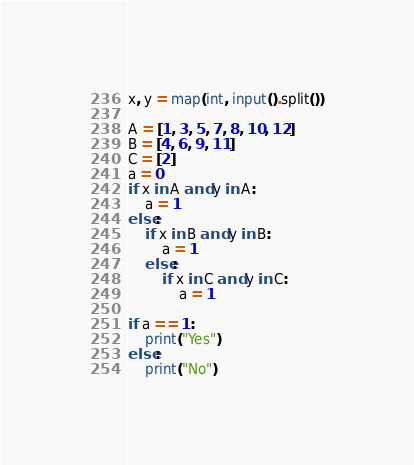<code> <loc_0><loc_0><loc_500><loc_500><_Python_>x, y = map(int, input().split())

A = [1, 3, 5, 7, 8, 10, 12]
B = [4, 6, 9, 11]
C = [2]
a = 0
if x in A and y in A:
    a = 1
else:
    if x in B and y in B:
        a = 1
    else:
        if x in C and y in C:
            a = 1

if a == 1:
    print("Yes")
else:
    print("No")
</code> 